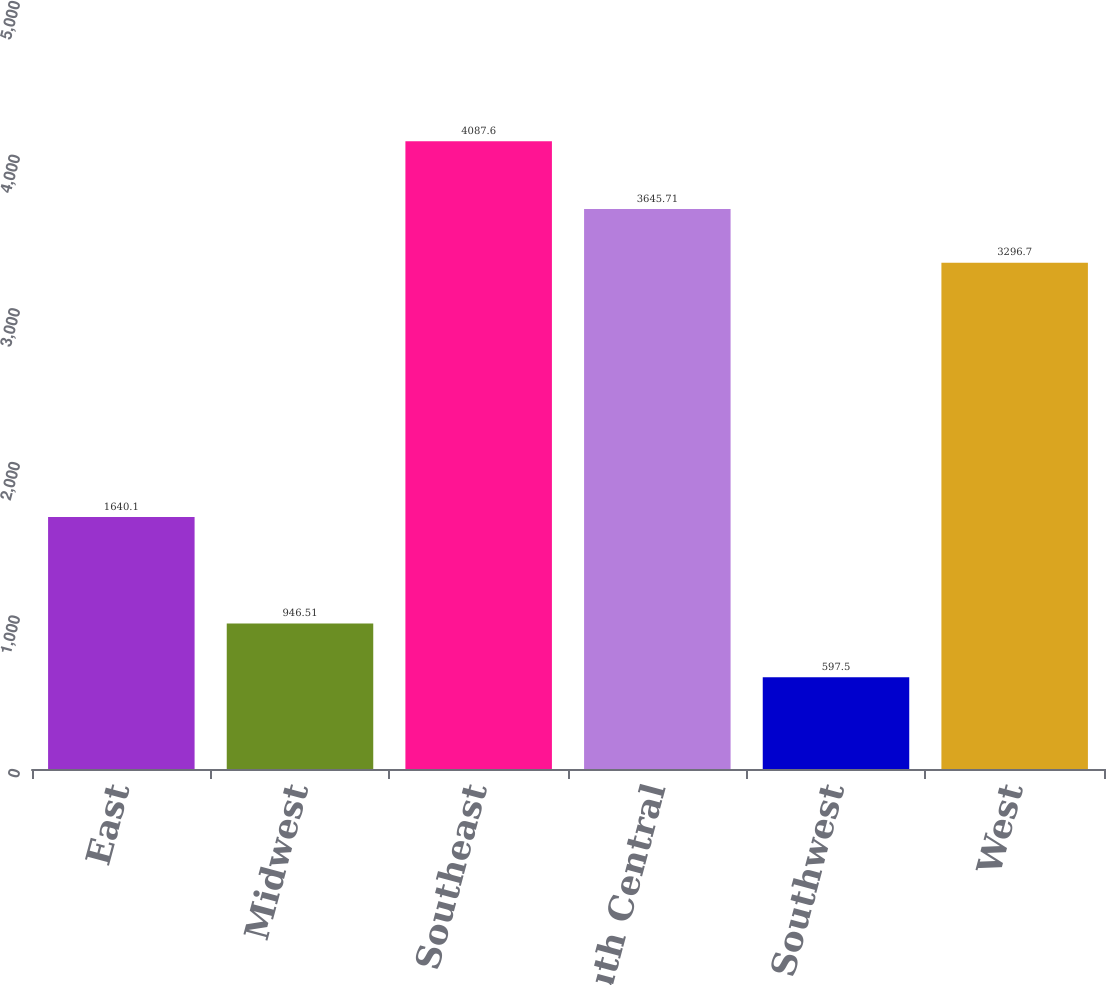Convert chart to OTSL. <chart><loc_0><loc_0><loc_500><loc_500><bar_chart><fcel>East<fcel>Midwest<fcel>Southeast<fcel>South Central<fcel>Southwest<fcel>West<nl><fcel>1640.1<fcel>946.51<fcel>4087.6<fcel>3645.71<fcel>597.5<fcel>3296.7<nl></chart> 